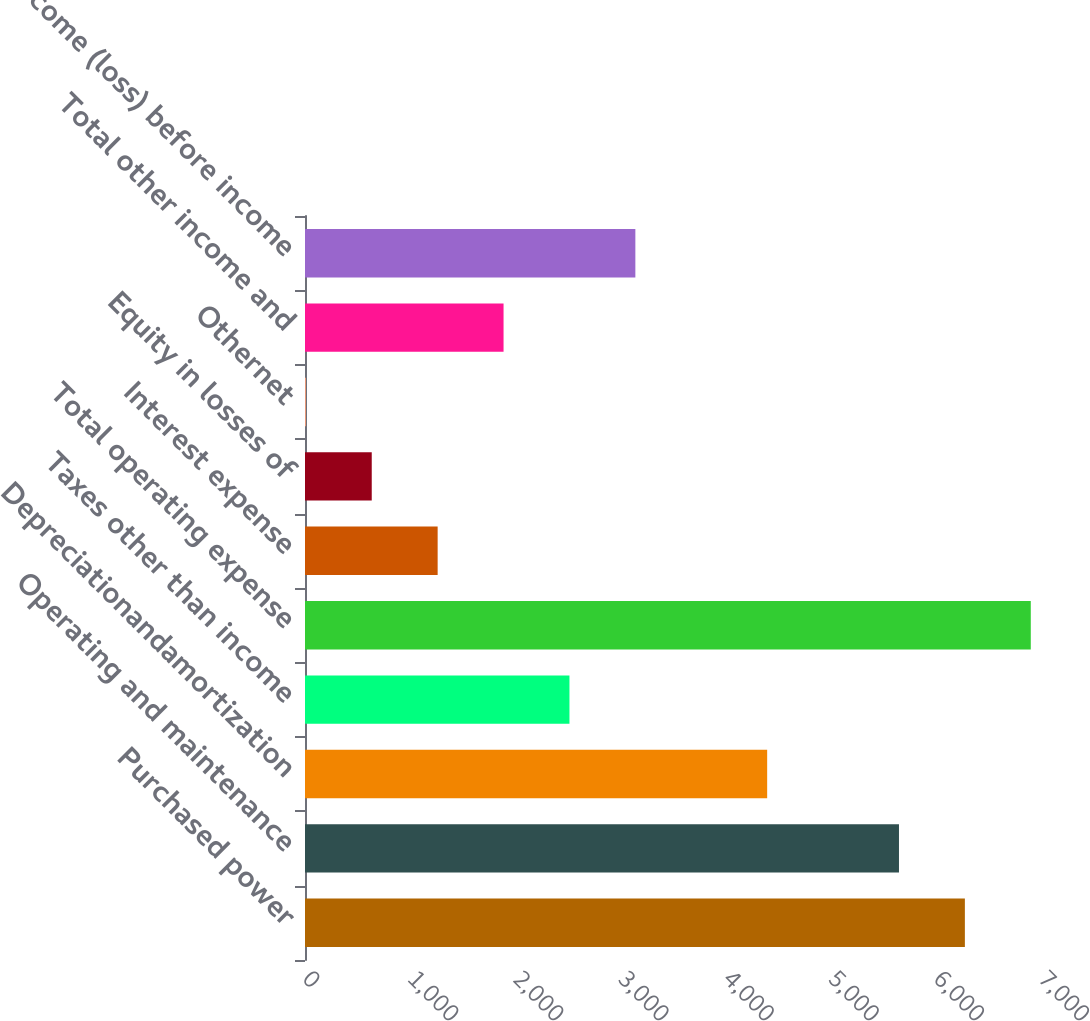<chart> <loc_0><loc_0><loc_500><loc_500><bar_chart><fcel>Purchased power<fcel>Operating and maintenance<fcel>Depreciationandamortization<fcel>Taxes other than income<fcel>Total operating expense<fcel>Interest expense<fcel>Equity in losses of<fcel>Othernet<fcel>Total other income and<fcel>Income (loss) before income<nl><fcel>6276<fcel>5649.2<fcel>4395.6<fcel>2515.2<fcel>6902.8<fcel>1261.6<fcel>634.8<fcel>8<fcel>1888.4<fcel>3142<nl></chart> 